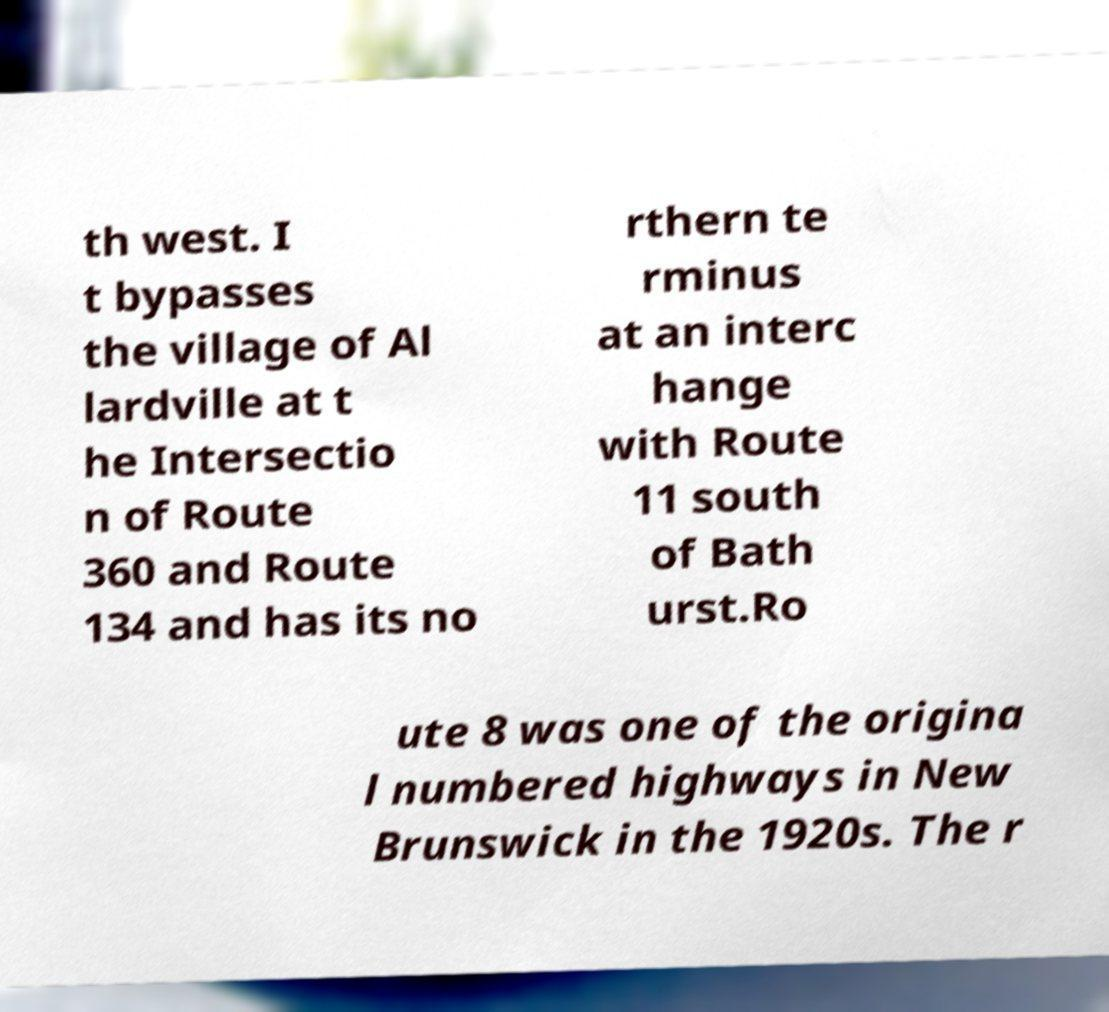Could you assist in decoding the text presented in this image and type it out clearly? th west. I t bypasses the village of Al lardville at t he Intersectio n of Route 360 and Route 134 and has its no rthern te rminus at an interc hange with Route 11 south of Bath urst.Ro ute 8 was one of the origina l numbered highways in New Brunswick in the 1920s. The r 